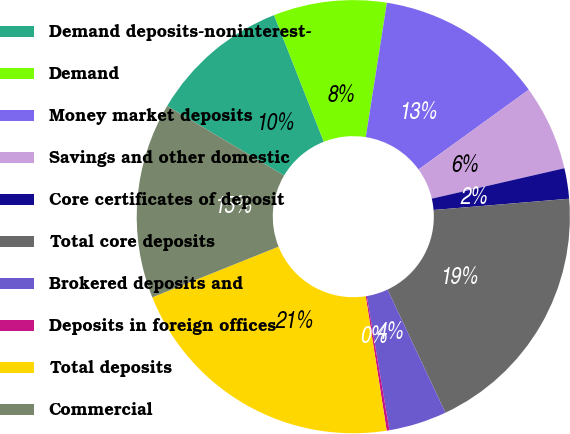Convert chart to OTSL. <chart><loc_0><loc_0><loc_500><loc_500><pie_chart><fcel>Demand deposits-noninterest-<fcel>Demand<fcel>Money market deposits<fcel>Savings and other domestic<fcel>Core certificates of deposit<fcel>Total core deposits<fcel>Brokered deposits and<fcel>Deposits in foreign offices<fcel>Total deposits<fcel>Commercial<nl><fcel>10.5%<fcel>8.44%<fcel>12.55%<fcel>6.38%<fcel>2.27%<fcel>19.33%<fcel>4.32%<fcel>0.21%<fcel>21.39%<fcel>14.61%<nl></chart> 